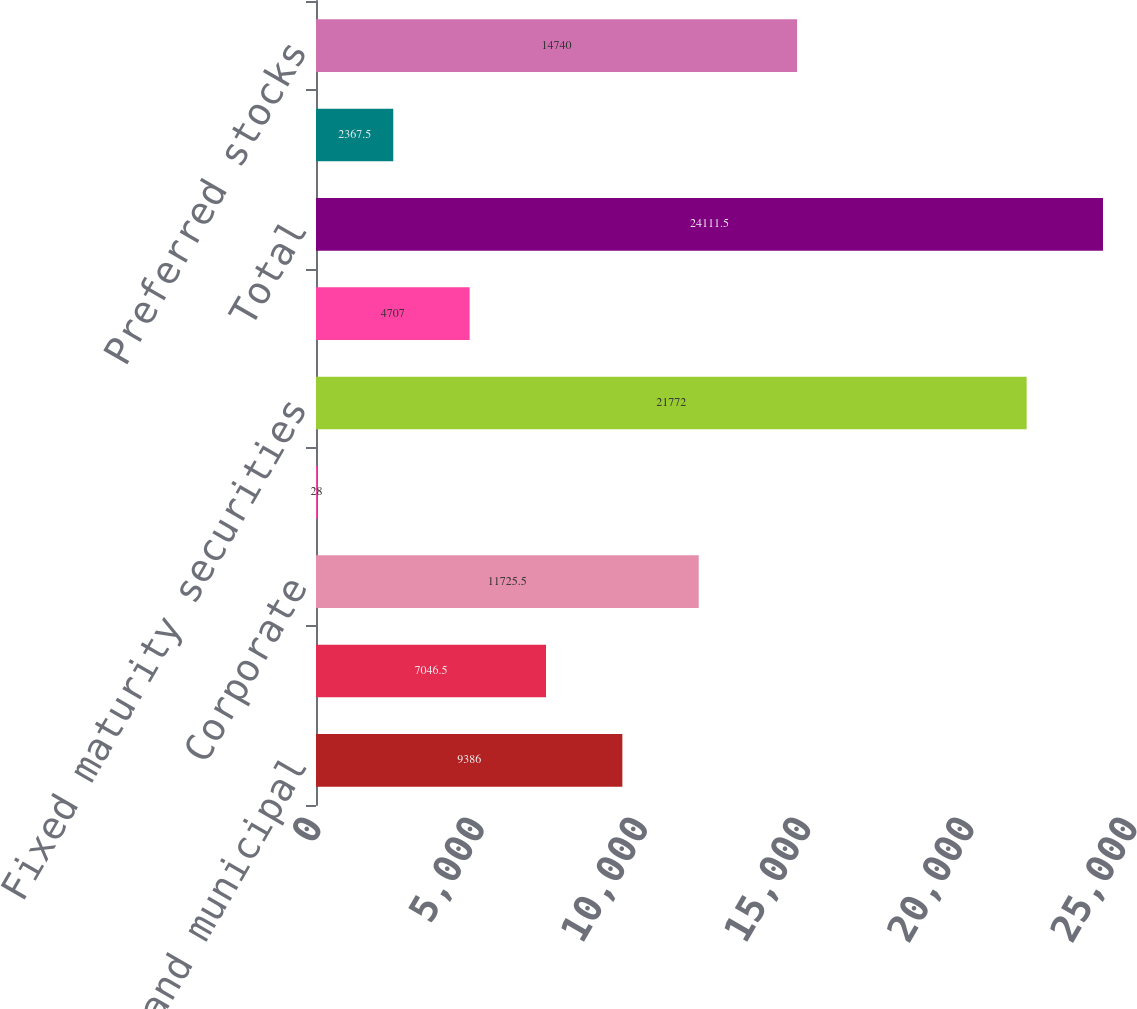Convert chart to OTSL. <chart><loc_0><loc_0><loc_500><loc_500><bar_chart><fcel>State and municipal<fcel>Mortgage-backed securities<fcel>Corporate<fcel>Foreign<fcel>Fixed maturity securities<fcel>Equity securities available<fcel>Total<fcel>US government and government<fcel>Preferred stocks<nl><fcel>9386<fcel>7046.5<fcel>11725.5<fcel>28<fcel>21772<fcel>4707<fcel>24111.5<fcel>2367.5<fcel>14740<nl></chart> 